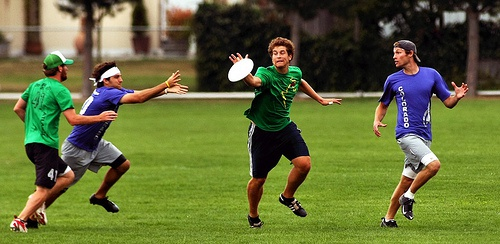Describe the objects in this image and their specific colors. I can see people in tan, black, maroon, darkgreen, and brown tones, people in tan, black, blue, lightgray, and darkblue tones, people in tan, black, green, darkgreen, and lightgreen tones, people in tan, black, gray, maroon, and white tones, and frisbee in tan, white, darkgray, black, and gray tones in this image. 